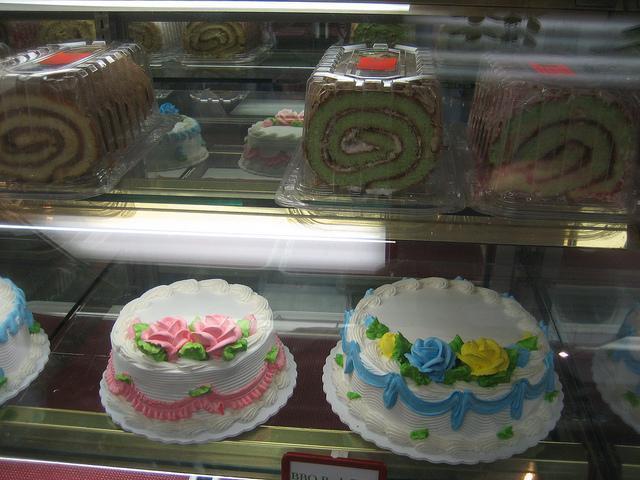How many cakes are in the photo?
Give a very brief answer. 10. How many people are holding a camera?
Give a very brief answer. 0. 